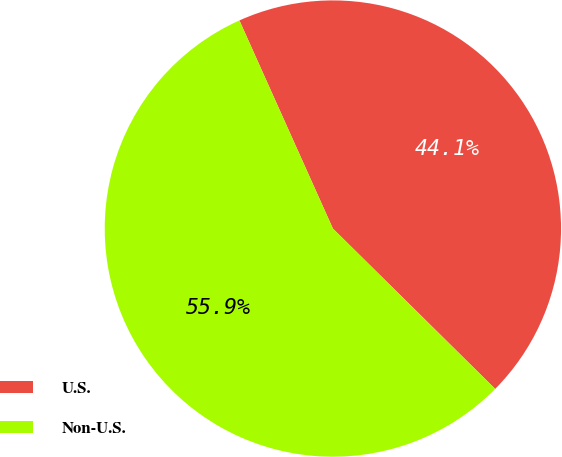Convert chart. <chart><loc_0><loc_0><loc_500><loc_500><pie_chart><fcel>U.S.<fcel>Non-U.S.<nl><fcel>44.12%<fcel>55.88%<nl></chart> 